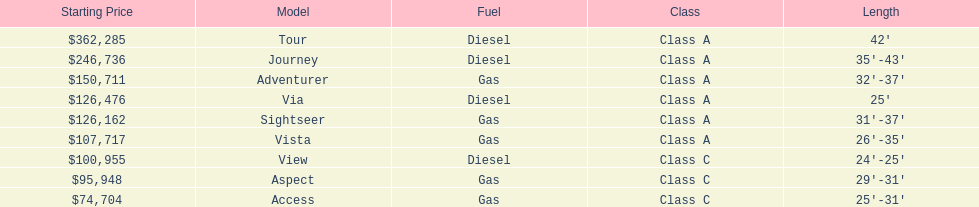Does the tour take diesel or gas? Diesel. 